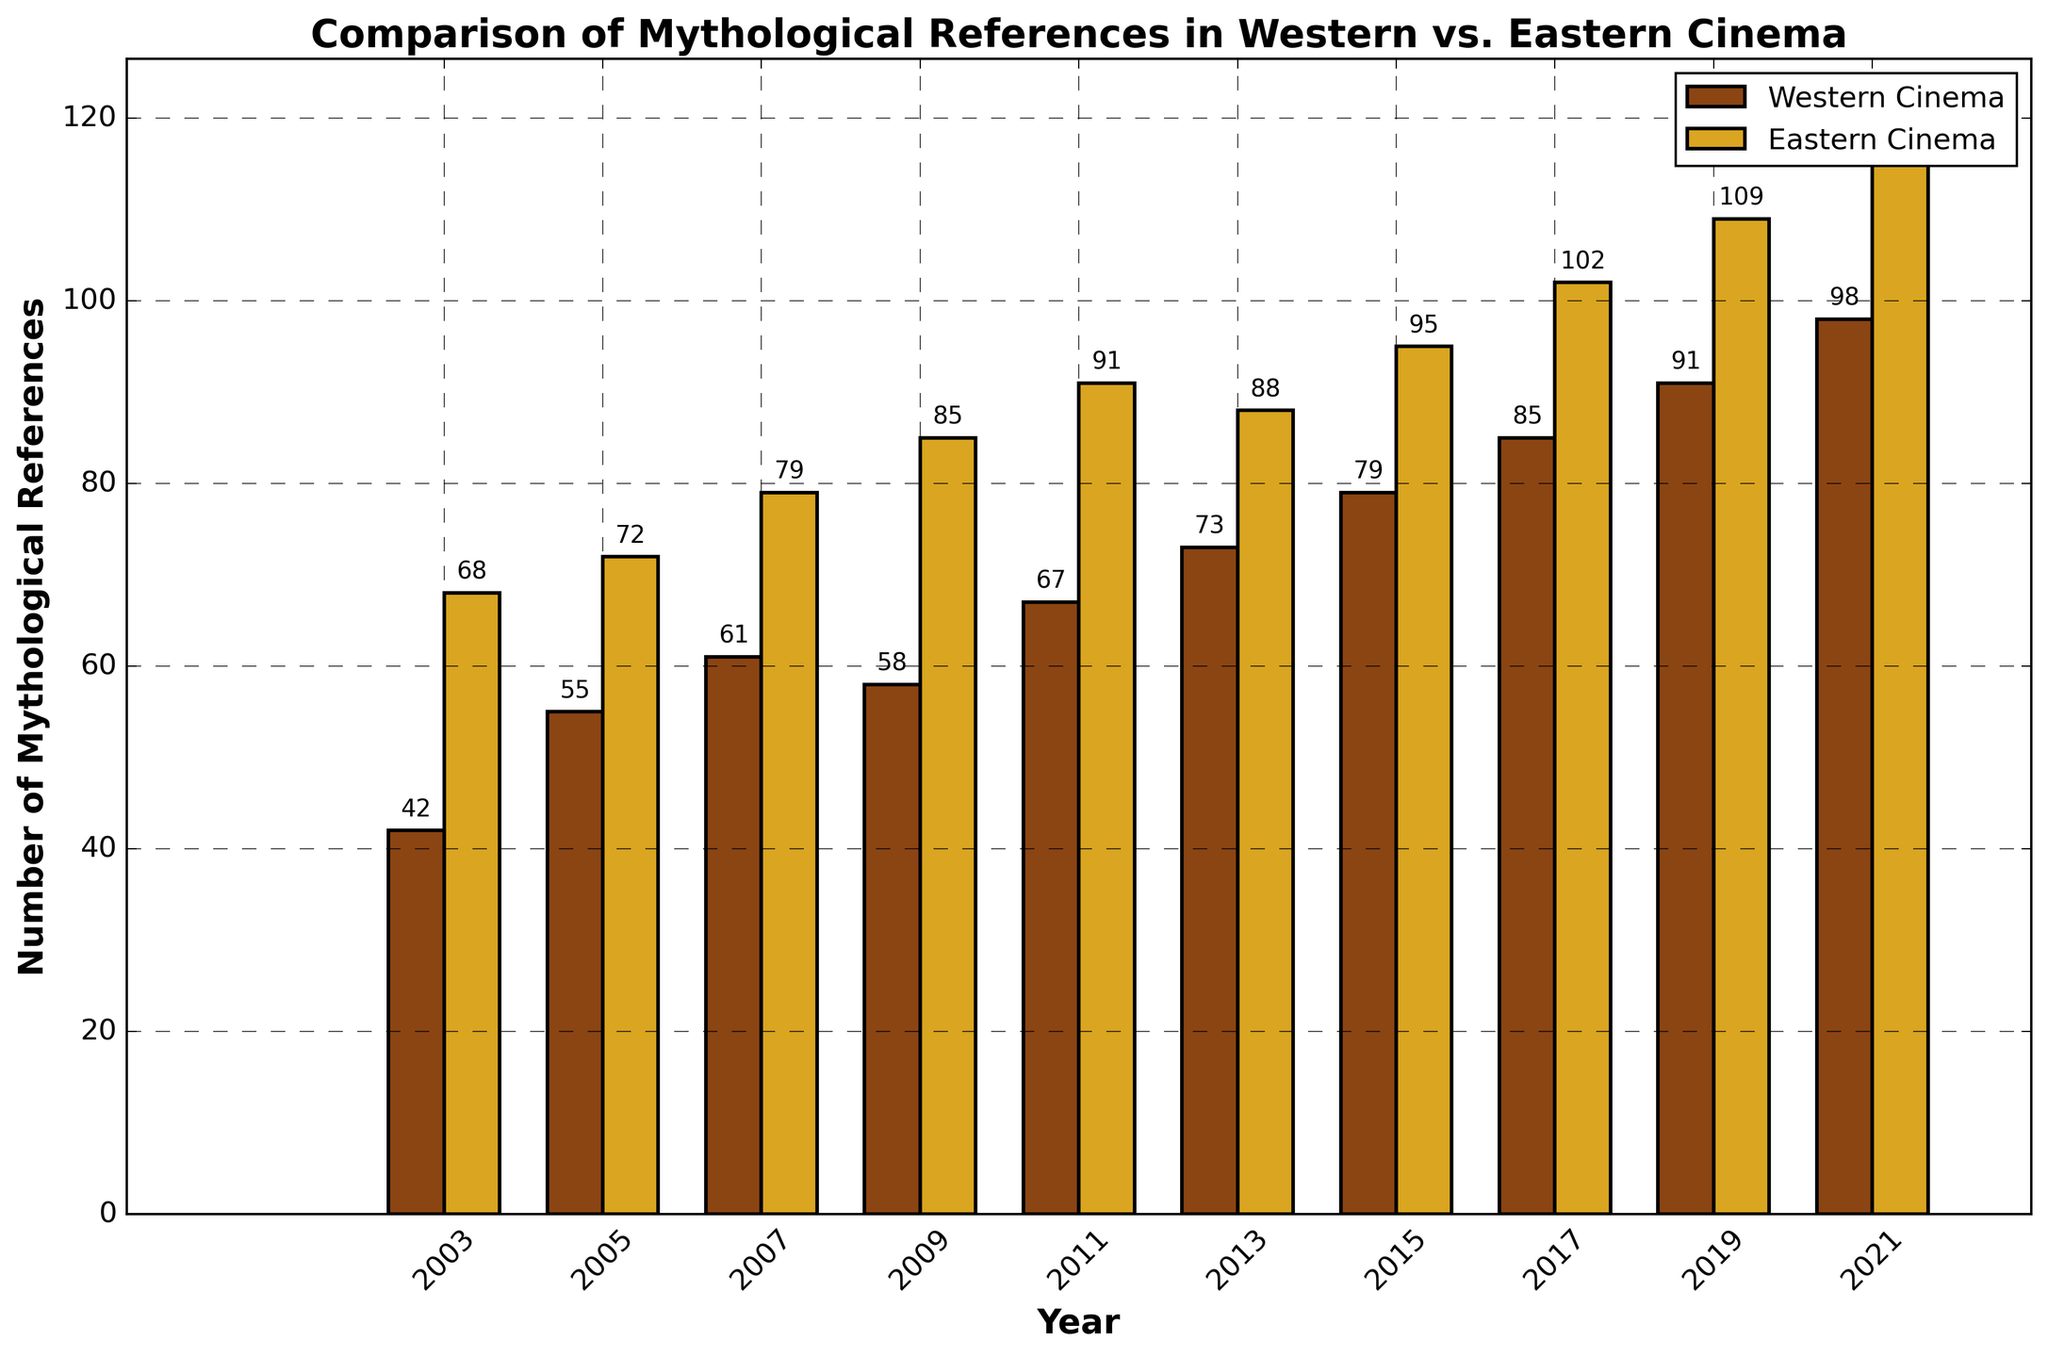What is the trend in mythological references in Western cinema from 2003 to 2021? The trend shows a general increase in the number of mythological references in Western cinema, starting from 42 in 2003 and reaching 98 in 2021.
Answer: General increase Which year saw the highest number of mythological references in Eastern cinema? The year 2021 saw the highest number of mythological references in Eastern cinema, with a total of 115 references.
Answer: 2021 How many more mythological references were there in Eastern cinema than Western cinema in 2019? In 2019, Eastern cinema had 109 references, whereas Western cinema had 91. The difference is 109 - 91 = 18.
Answer: 18 What is the average number of mythological references in Western cinema over the years 2003, 2009, and 2015? The mythological references in Western cinema for the years 2003, 2009, and 2015 are 42, 58, and 79 respectively. The sum is 42 + 58 + 79 = 179, and the average is 179/3 = 59.67.
Answer: 59.67 In which year did Western and Eastern cinema show the smallest difference in mythological references, and what was that difference? The smallest difference occurred in 2013, where Western cinema had 73 references and Eastern cinema had 88. The difference is 88 - 73 = 15.
Answer: 2013, 15 Between which consecutive years did Eastern cinema show the largest increase in mythological references? The largest increase in references in Eastern cinema between consecutive years was from 2017 (102 references) to 2019 (109 references). The increase is 109 - 102 = 7.
Answer: 2017 to 2019, 7 Did Western cinema ever surpass Eastern cinema in mythological references from 2003 to 2021? No, at no point did Western cinema have more mythological references than Eastern cinema from 2003 to 2021.
Answer: No What was the median number of mythological references in Western cinema over these 10 data points? To find the median, list the data points in order: 42, 55, 58, 61, 67, 73, 79, 85, 91, 98. The median is the average of the 5th and 6th values: (67 + 73)/2 = 70.
Answer: 70 